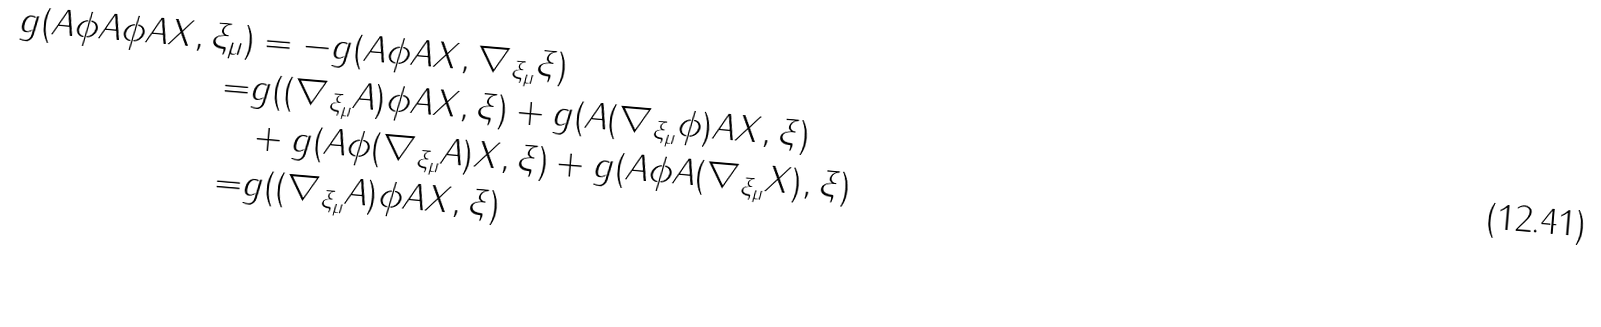Convert formula to latex. <formula><loc_0><loc_0><loc_500><loc_500>g ( A \phi A \phi A X , \xi _ { \mu } ) & = - g ( A \phi A X , \nabla _ { \xi _ { \mu } } \xi ) \\ = & g ( ( \nabla _ { \xi _ { \mu } } A ) \phi A X , \xi ) + g ( A ( \nabla _ { \xi _ { \mu } } \phi ) A X , \xi ) \\ & + g ( A \phi ( \nabla _ { \xi _ { \mu } } A ) X , \xi ) + g ( A \phi A ( \nabla _ { \xi _ { \mu } } X ) , \xi ) \\ = & g ( ( { \nabla } _ { \xi _ { \mu } } A ) { \phi } A X , { \xi } )</formula> 